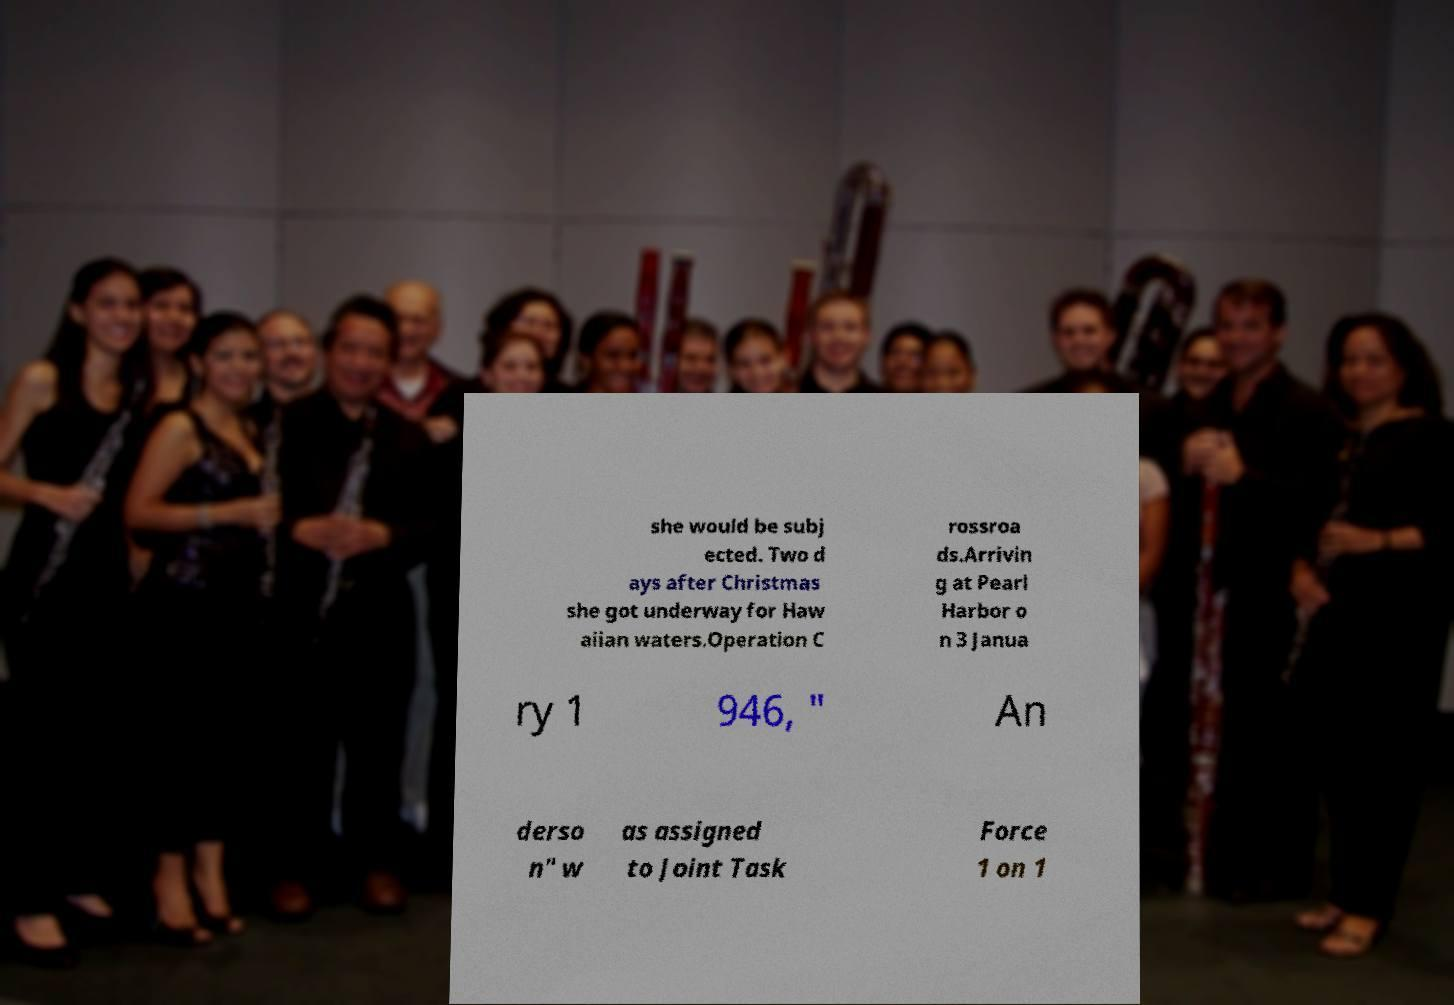I need the written content from this picture converted into text. Can you do that? she would be subj ected. Two d ays after Christmas she got underway for Haw aiian waters.Operation C rossroa ds.Arrivin g at Pearl Harbor o n 3 Janua ry 1 946, " An derso n" w as assigned to Joint Task Force 1 on 1 